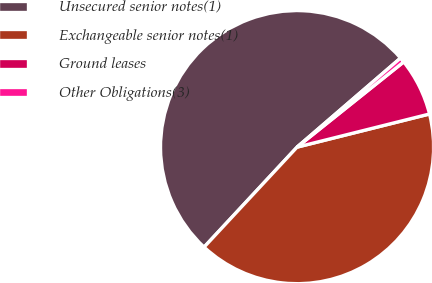Convert chart. <chart><loc_0><loc_0><loc_500><loc_500><pie_chart><fcel>Unsecured senior notes(1)<fcel>Exchangeable senior notes(1)<fcel>Ground leases<fcel>Other Obligations(3)<nl><fcel>51.77%<fcel>40.83%<fcel>6.83%<fcel>0.58%<nl></chart> 